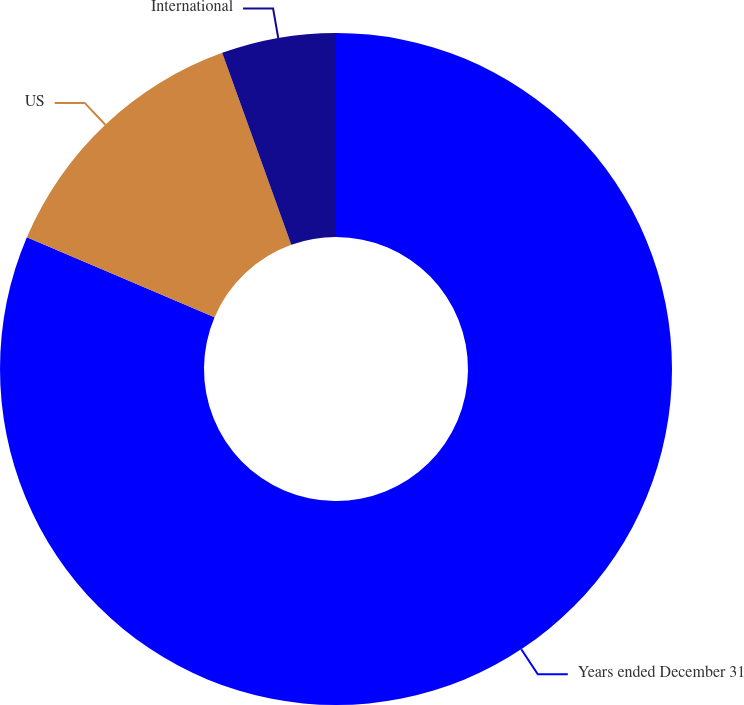Convert chart to OTSL. <chart><loc_0><loc_0><loc_500><loc_500><pie_chart><fcel>Years ended December 31<fcel>US<fcel>International<nl><fcel>81.41%<fcel>13.09%<fcel>5.5%<nl></chart> 